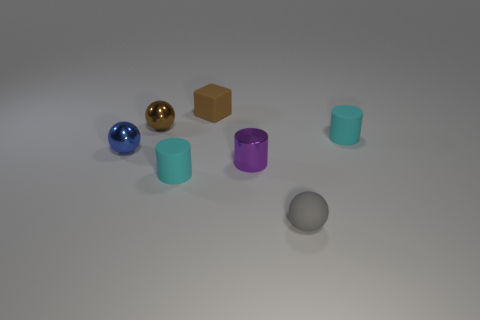What size is the blue metal object?
Keep it short and to the point. Small. What number of tiny objects are to the left of the gray matte sphere and in front of the shiny cylinder?
Offer a terse response. 1. The tiny cylinder behind the tiny blue ball that is behind the cyan cylinder that is on the left side of the small brown rubber cube is what color?
Give a very brief answer. Cyan. There is a small cyan cylinder behind the purple cylinder; what number of small brown rubber blocks are behind it?
Make the answer very short. 1. What number of other objects are the same shape as the blue metal object?
Your response must be concise. 2. How many things are either tiny brown metallic objects or small rubber objects on the right side of the small gray rubber thing?
Your answer should be compact. 2. Is the number of tiny gray rubber objects that are in front of the gray thing greater than the number of metal spheres that are left of the small brown cube?
Make the answer very short. No. There is a tiny brown thing on the left side of the tiny rubber cube on the right side of the blue thing that is to the left of the small shiny cylinder; what shape is it?
Ensure brevity in your answer.  Sphere. What is the shape of the tiny cyan thing left of the tiny matte cylinder that is to the right of the gray object?
Your answer should be compact. Cylinder. Is there a tiny cube that has the same material as the tiny gray object?
Ensure brevity in your answer.  Yes. 